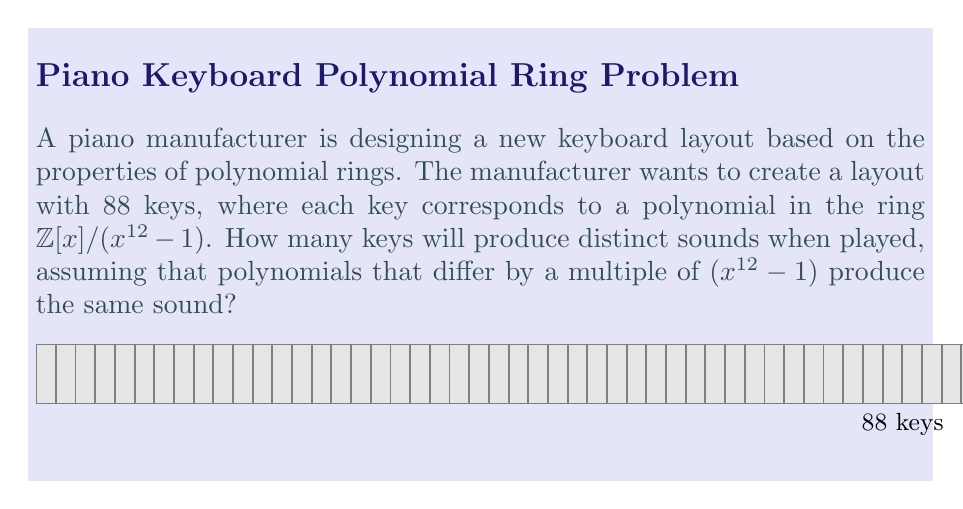Show me your answer to this math problem. Let's approach this step-by-step:

1) The ring $\mathbb{Z}[x]/(x^{12} - 1)$ is a quotient ring of polynomials with integer coefficients modulo $(x^{12} - 1)$.

2) In this ring, two polynomials $f(x)$ and $g(x)$ are equivalent if and only if $f(x) - g(x)$ is divisible by $(x^{12} - 1)$.

3) The number of distinct elements in this ring is equal to the number of possible remainders when dividing a polynomial by $(x^{12} - 1)$.

4) Any polynomial divided by $(x^{12} - 1)$ will have a remainder of degree less than 12.

5) The general form of such a remainder is:

   $a_0 + a_1x + a_2x^2 + ... + a_{11}x^{11}$

   where $a_0, a_1, ..., a_{11}$ are integers.

6) However, we need to consider that the coefficients are from $\mathbb{Z}$, which is infinite. This would make our ring infinite as well.

7) For a finite keyboard, we need to limit the range of coefficients. Let's assume the manufacturer uses a standard equal temperament system with 12 semitones per octave.

8) In this case, we can consider the coefficients modulo 12, as there are 12 distinct pitch classes in an octave.

9) Now, each coefficient $a_i$ can take 12 possible values (0 to 11).

10) Therefore, the total number of distinct polynomials (and thus distinct sounds) is:

    $12^{12} = 8,916,100,448,256$

This is much larger than 88, so all 88 keys will produce distinct sounds.
Answer: 88 